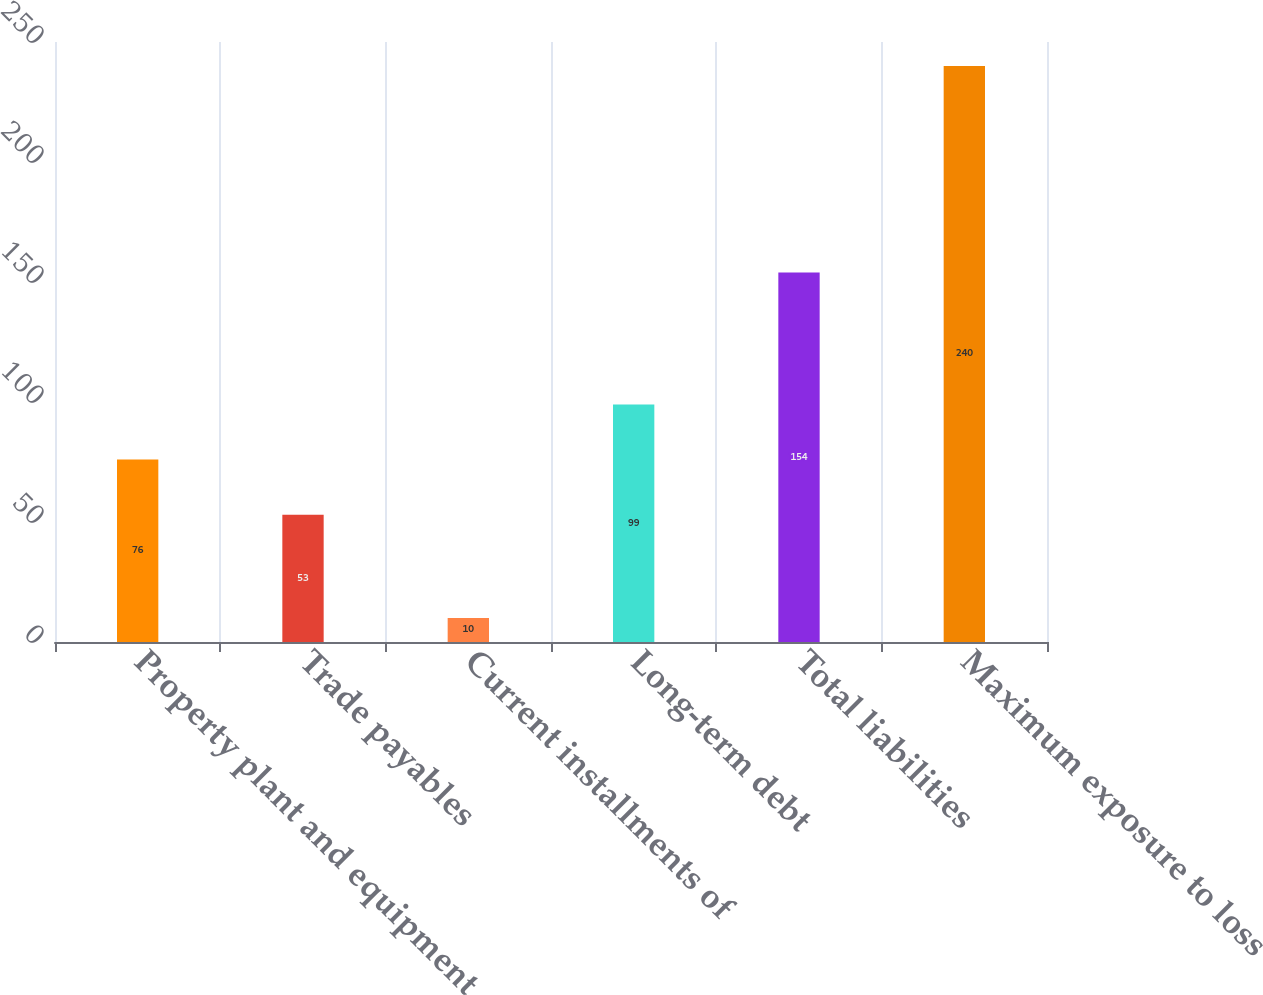Convert chart to OTSL. <chart><loc_0><loc_0><loc_500><loc_500><bar_chart><fcel>Property plant and equipment<fcel>Trade payables<fcel>Current installments of<fcel>Long-term debt<fcel>Total liabilities<fcel>Maximum exposure to loss<nl><fcel>76<fcel>53<fcel>10<fcel>99<fcel>154<fcel>240<nl></chart> 